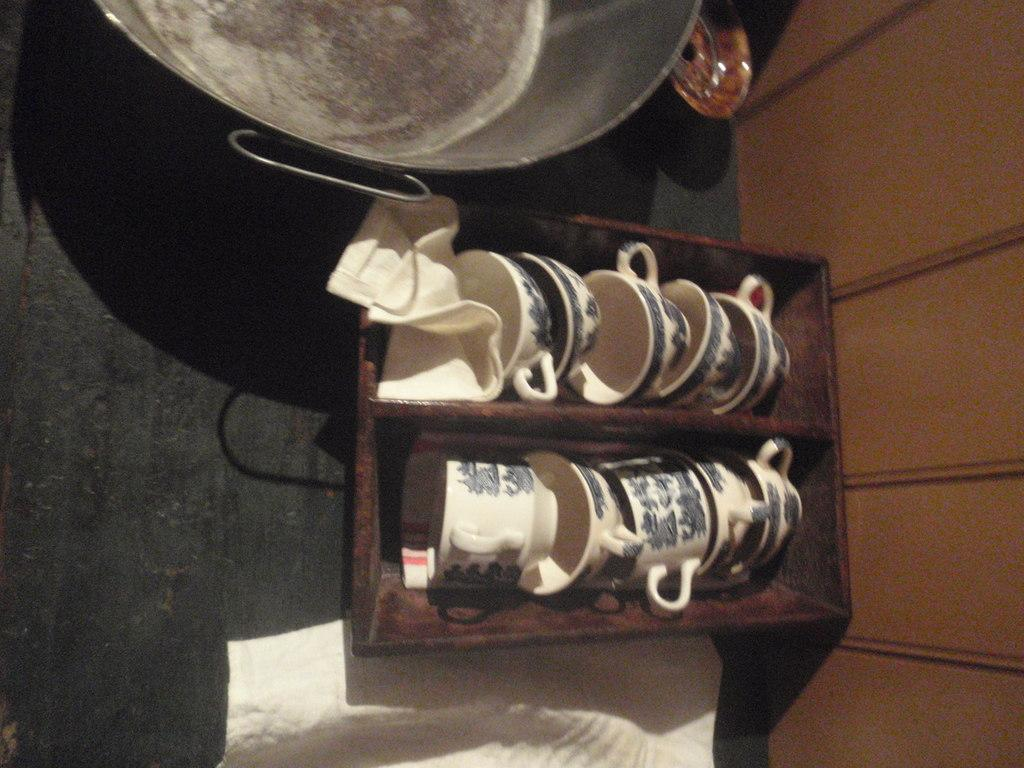What type of items can be seen in the image? There are cups, clothes, and a bowl in the image. What else is present in the image besides these items? There are other objects present in the image. Where are these items placed? All these items are placed on a surface. What can be seen in the background of the image? There is a wall visible in the background of the image. What type of soup is being served in the bowl in the image? There is no soup present in the image; it features a bowl, cups, clothes, and other objects on a surface. What is the bear doing in the image? There is no bear present in the image. 